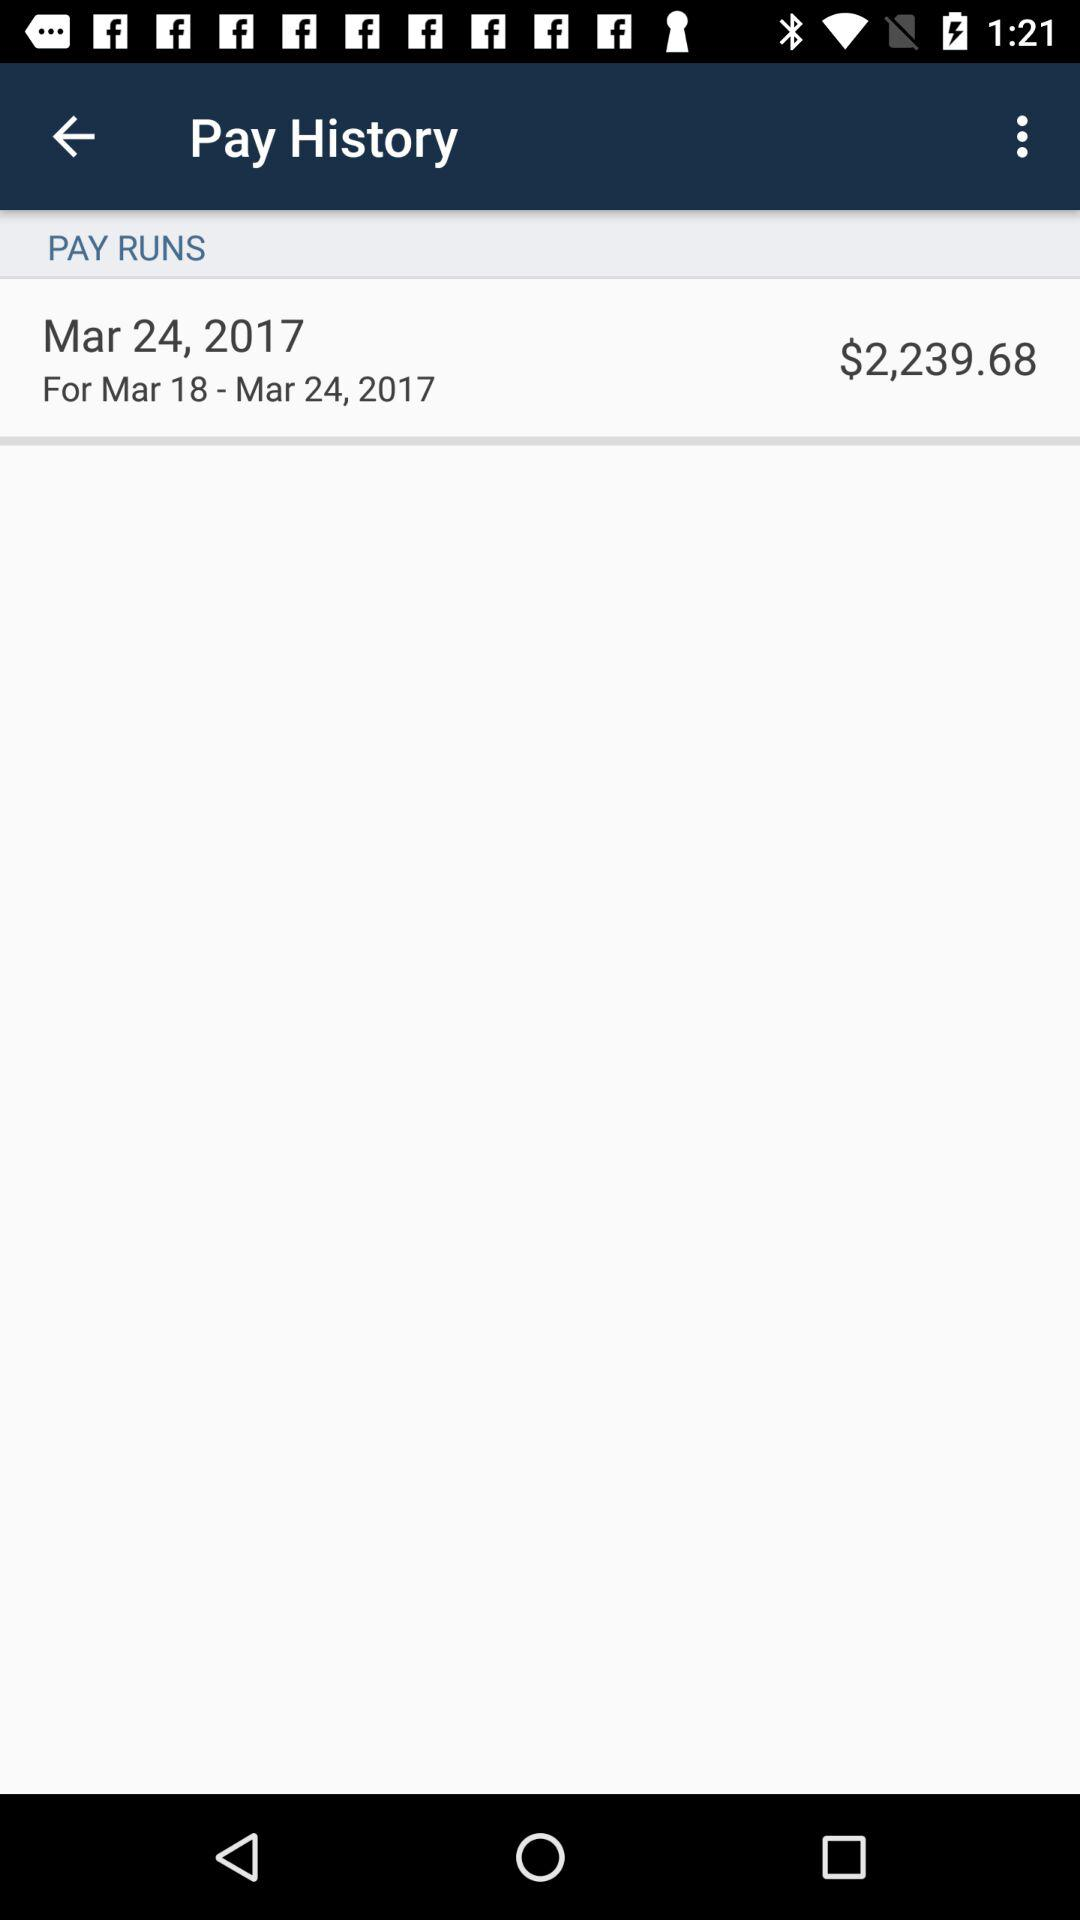How much was the pay?
Answer the question using a single word or phrase. $2,239.68 